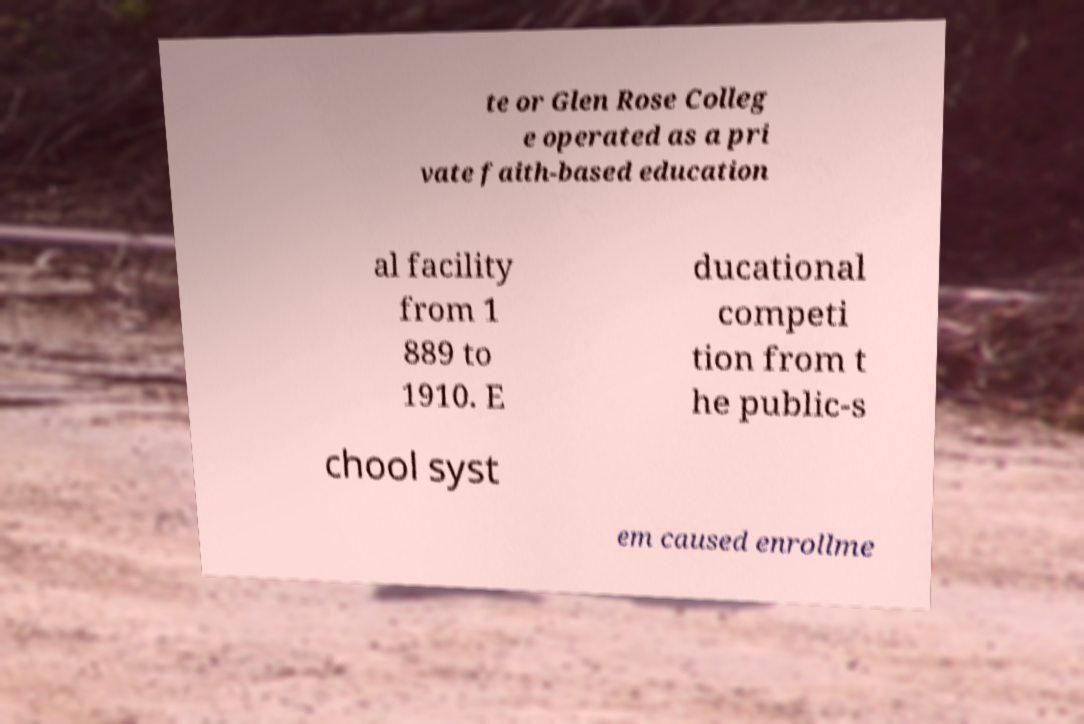Could you assist in decoding the text presented in this image and type it out clearly? te or Glen Rose Colleg e operated as a pri vate faith-based education al facility from 1 889 to 1910. E ducational competi tion from t he public-s chool syst em caused enrollme 